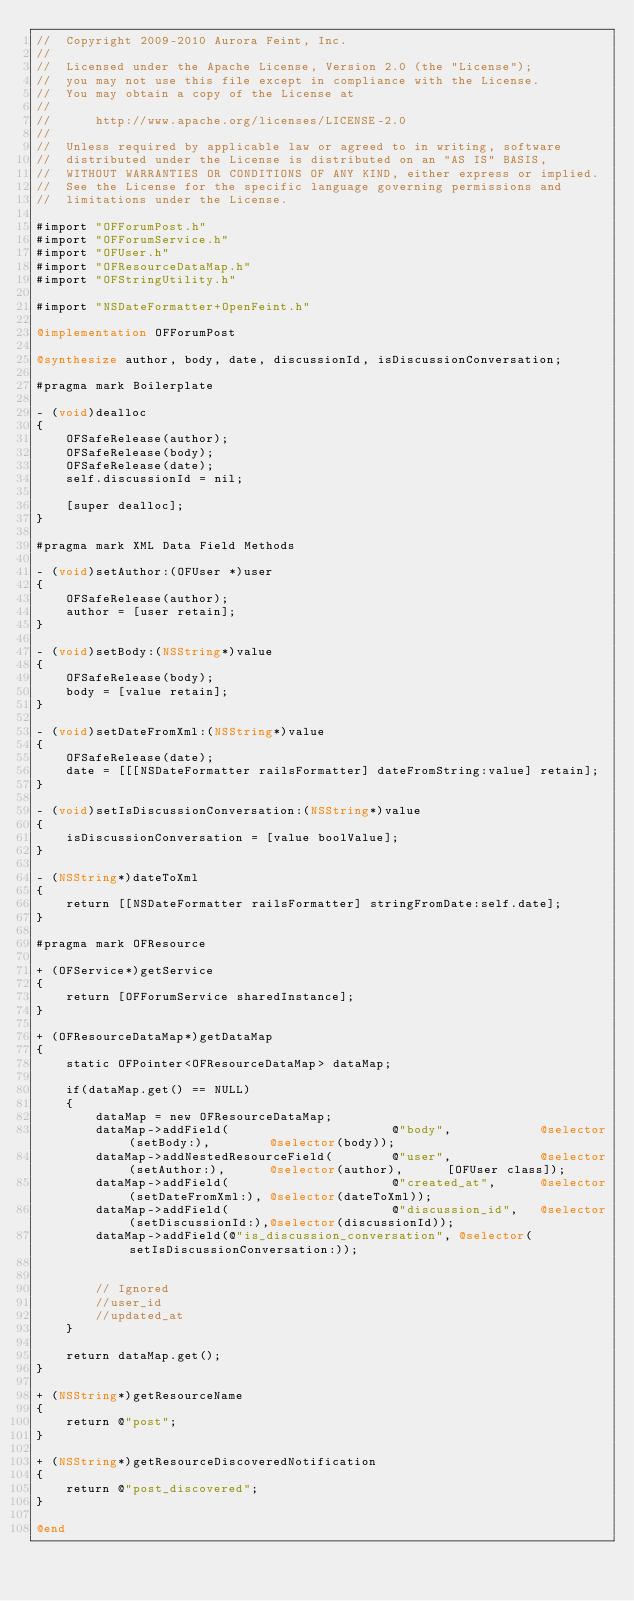Convert code to text. <code><loc_0><loc_0><loc_500><loc_500><_ObjectiveC_>//  Copyright 2009-2010 Aurora Feint, Inc.
// 
//  Licensed under the Apache License, Version 2.0 (the "License");
//  you may not use this file except in compliance with the License.
//  You may obtain a copy of the License at
//  
//  	http://www.apache.org/licenses/LICENSE-2.0
//  	
//  Unless required by applicable law or agreed to in writing, software
//  distributed under the License is distributed on an "AS IS" BASIS,
//  WITHOUT WARRANTIES OR CONDITIONS OF ANY KIND, either express or implied.
//  See the License for the specific language governing permissions and
//  limitations under the License.

#import "OFForumPost.h"
#import "OFForumService.h"
#import "OFUser.h"
#import "OFResourceDataMap.h"
#import "OFStringUtility.h"

#import "NSDateFormatter+OpenFeint.h"

@implementation OFForumPost

@synthesize author, body, date, discussionId, isDiscussionConversation;

#pragma mark Boilerplate

- (void)dealloc
{
	OFSafeRelease(author);
	OFSafeRelease(body);
	OFSafeRelease(date);
	self.discussionId = nil;
	
	[super dealloc];
}

#pragma mark XML Data Field Methods

- (void)setAuthor:(OFUser *)user
{
	OFSafeRelease(author);
	author = [user retain];
}

- (void)setBody:(NSString*)value
{
	OFSafeRelease(body);
	body = [value retain];
}

- (void)setDateFromXml:(NSString*)value
{
	OFSafeRelease(date);
	date = [[[NSDateFormatter railsFormatter] dateFromString:value] retain];
}

- (void)setIsDiscussionConversation:(NSString*)value
{
	isDiscussionConversation = [value boolValue];
}

- (NSString*)dateToXml
{
	return [[NSDateFormatter railsFormatter] stringFromDate:self.date];
}

#pragma mark OFResource

+ (OFService*)getService
{
	return [OFForumService sharedInstance];
}

+ (OFResourceDataMap*)getDataMap
{
	static OFPointer<OFResourceDataMap> dataMap;
	
	if(dataMap.get() == NULL)
	{
		dataMap = new OFResourceDataMap;
		dataMap->addField(						@"body",			@selector(setBody:),		@selector(body));
		dataMap->addNestedResourceField(		@"user",			@selector(setAuthor:),		@selector(author),		[OFUser class]);
		dataMap->addField(						@"created_at",		@selector(setDateFromXml:),	@selector(dateToXml));
		dataMap->addField(						@"discussion_id",	@selector(setDiscussionId:),@selector(discussionId));
		dataMap->addField(@"is_discussion_conversation", @selector(setIsDiscussionConversation:));

		
		// Ignored
		//user_id
		//updated_at
	}
	
	return dataMap.get();
}

+ (NSString*)getResourceName
{
	return @"post";
}

+ (NSString*)getResourceDiscoveredNotification
{
	return @"post_discovered";
}

@end
</code> 